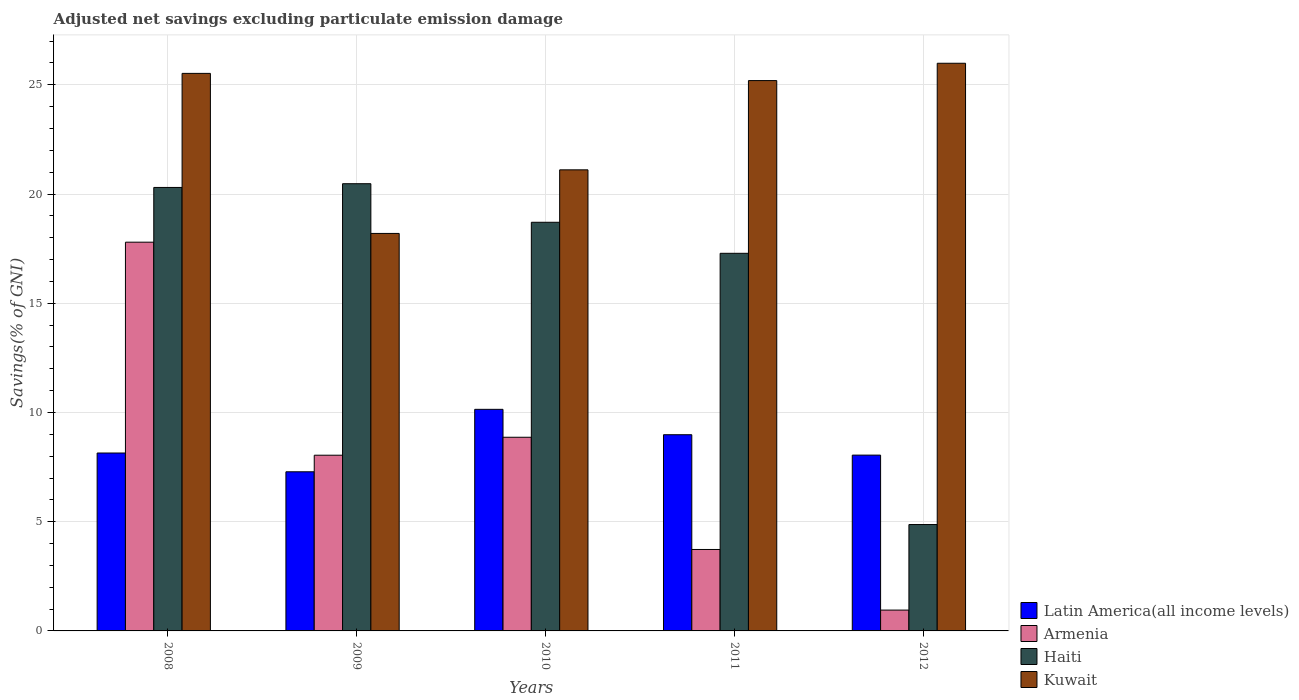How many different coloured bars are there?
Your answer should be compact. 4. Are the number of bars per tick equal to the number of legend labels?
Keep it short and to the point. Yes. Are the number of bars on each tick of the X-axis equal?
Your response must be concise. Yes. How many bars are there on the 3rd tick from the left?
Make the answer very short. 4. How many bars are there on the 2nd tick from the right?
Make the answer very short. 4. In how many cases, is the number of bars for a given year not equal to the number of legend labels?
Your response must be concise. 0. What is the adjusted net savings in Haiti in 2010?
Your answer should be compact. 18.71. Across all years, what is the maximum adjusted net savings in Kuwait?
Make the answer very short. 25.99. Across all years, what is the minimum adjusted net savings in Latin America(all income levels)?
Provide a short and direct response. 7.29. What is the total adjusted net savings in Kuwait in the graph?
Offer a terse response. 116.01. What is the difference between the adjusted net savings in Armenia in 2009 and that in 2011?
Ensure brevity in your answer.  4.32. What is the difference between the adjusted net savings in Armenia in 2008 and the adjusted net savings in Latin America(all income levels) in 2010?
Make the answer very short. 7.65. What is the average adjusted net savings in Haiti per year?
Make the answer very short. 16.33. In the year 2012, what is the difference between the adjusted net savings in Armenia and adjusted net savings in Haiti?
Make the answer very short. -3.92. In how many years, is the adjusted net savings in Latin America(all income levels) greater than 25 %?
Provide a short and direct response. 0. What is the ratio of the adjusted net savings in Latin America(all income levels) in 2008 to that in 2010?
Give a very brief answer. 0.8. What is the difference between the highest and the second highest adjusted net savings in Kuwait?
Your response must be concise. 0.46. What is the difference between the highest and the lowest adjusted net savings in Haiti?
Offer a terse response. 15.6. In how many years, is the adjusted net savings in Haiti greater than the average adjusted net savings in Haiti taken over all years?
Offer a very short reply. 4. What does the 3rd bar from the left in 2010 represents?
Provide a short and direct response. Haiti. What does the 1st bar from the right in 2012 represents?
Give a very brief answer. Kuwait. How many bars are there?
Ensure brevity in your answer.  20. What is the difference between two consecutive major ticks on the Y-axis?
Provide a short and direct response. 5. How many legend labels are there?
Provide a short and direct response. 4. How are the legend labels stacked?
Provide a short and direct response. Vertical. What is the title of the graph?
Offer a terse response. Adjusted net savings excluding particulate emission damage. What is the label or title of the Y-axis?
Offer a terse response. Savings(% of GNI). What is the Savings(% of GNI) of Latin America(all income levels) in 2008?
Your answer should be compact. 8.14. What is the Savings(% of GNI) of Armenia in 2008?
Provide a succinct answer. 17.8. What is the Savings(% of GNI) in Haiti in 2008?
Your answer should be very brief. 20.3. What is the Savings(% of GNI) of Kuwait in 2008?
Provide a short and direct response. 25.52. What is the Savings(% of GNI) of Latin America(all income levels) in 2009?
Keep it short and to the point. 7.29. What is the Savings(% of GNI) in Armenia in 2009?
Make the answer very short. 8.04. What is the Savings(% of GNI) in Haiti in 2009?
Your answer should be very brief. 20.47. What is the Savings(% of GNI) in Kuwait in 2009?
Provide a short and direct response. 18.2. What is the Savings(% of GNI) of Latin America(all income levels) in 2010?
Ensure brevity in your answer.  10.14. What is the Savings(% of GNI) of Armenia in 2010?
Make the answer very short. 8.87. What is the Savings(% of GNI) in Haiti in 2010?
Provide a succinct answer. 18.71. What is the Savings(% of GNI) of Kuwait in 2010?
Give a very brief answer. 21.11. What is the Savings(% of GNI) of Latin America(all income levels) in 2011?
Your response must be concise. 8.98. What is the Savings(% of GNI) in Armenia in 2011?
Your response must be concise. 3.73. What is the Savings(% of GNI) in Haiti in 2011?
Provide a succinct answer. 17.29. What is the Savings(% of GNI) of Kuwait in 2011?
Ensure brevity in your answer.  25.19. What is the Savings(% of GNI) of Latin America(all income levels) in 2012?
Make the answer very short. 8.05. What is the Savings(% of GNI) in Armenia in 2012?
Ensure brevity in your answer.  0.95. What is the Savings(% of GNI) in Haiti in 2012?
Provide a succinct answer. 4.87. What is the Savings(% of GNI) of Kuwait in 2012?
Your response must be concise. 25.99. Across all years, what is the maximum Savings(% of GNI) of Latin America(all income levels)?
Your answer should be compact. 10.14. Across all years, what is the maximum Savings(% of GNI) in Armenia?
Provide a succinct answer. 17.8. Across all years, what is the maximum Savings(% of GNI) of Haiti?
Offer a very short reply. 20.47. Across all years, what is the maximum Savings(% of GNI) in Kuwait?
Offer a very short reply. 25.99. Across all years, what is the minimum Savings(% of GNI) in Latin America(all income levels)?
Give a very brief answer. 7.29. Across all years, what is the minimum Savings(% of GNI) of Armenia?
Ensure brevity in your answer.  0.95. Across all years, what is the minimum Savings(% of GNI) of Haiti?
Your response must be concise. 4.87. Across all years, what is the minimum Savings(% of GNI) of Kuwait?
Provide a succinct answer. 18.2. What is the total Savings(% of GNI) of Latin America(all income levels) in the graph?
Ensure brevity in your answer.  42.6. What is the total Savings(% of GNI) in Armenia in the graph?
Keep it short and to the point. 39.39. What is the total Savings(% of GNI) of Haiti in the graph?
Make the answer very short. 81.64. What is the total Savings(% of GNI) in Kuwait in the graph?
Offer a very short reply. 116.01. What is the difference between the Savings(% of GNI) in Latin America(all income levels) in 2008 and that in 2009?
Provide a succinct answer. 0.86. What is the difference between the Savings(% of GNI) in Armenia in 2008 and that in 2009?
Ensure brevity in your answer.  9.75. What is the difference between the Savings(% of GNI) of Haiti in 2008 and that in 2009?
Offer a terse response. -0.17. What is the difference between the Savings(% of GNI) in Kuwait in 2008 and that in 2009?
Offer a very short reply. 7.33. What is the difference between the Savings(% of GNI) of Latin America(all income levels) in 2008 and that in 2010?
Offer a terse response. -2. What is the difference between the Savings(% of GNI) of Armenia in 2008 and that in 2010?
Provide a short and direct response. 8.93. What is the difference between the Savings(% of GNI) of Haiti in 2008 and that in 2010?
Give a very brief answer. 1.59. What is the difference between the Savings(% of GNI) in Kuwait in 2008 and that in 2010?
Offer a very short reply. 4.42. What is the difference between the Savings(% of GNI) in Latin America(all income levels) in 2008 and that in 2011?
Offer a terse response. -0.84. What is the difference between the Savings(% of GNI) of Armenia in 2008 and that in 2011?
Your response must be concise. 14.07. What is the difference between the Savings(% of GNI) of Haiti in 2008 and that in 2011?
Your response must be concise. 3.02. What is the difference between the Savings(% of GNI) in Kuwait in 2008 and that in 2011?
Provide a short and direct response. 0.33. What is the difference between the Savings(% of GNI) in Latin America(all income levels) in 2008 and that in 2012?
Your answer should be very brief. 0.1. What is the difference between the Savings(% of GNI) in Armenia in 2008 and that in 2012?
Your answer should be compact. 16.84. What is the difference between the Savings(% of GNI) in Haiti in 2008 and that in 2012?
Keep it short and to the point. 15.43. What is the difference between the Savings(% of GNI) in Kuwait in 2008 and that in 2012?
Your response must be concise. -0.46. What is the difference between the Savings(% of GNI) in Latin America(all income levels) in 2009 and that in 2010?
Keep it short and to the point. -2.86. What is the difference between the Savings(% of GNI) of Armenia in 2009 and that in 2010?
Make the answer very short. -0.82. What is the difference between the Savings(% of GNI) of Haiti in 2009 and that in 2010?
Keep it short and to the point. 1.77. What is the difference between the Savings(% of GNI) of Kuwait in 2009 and that in 2010?
Keep it short and to the point. -2.91. What is the difference between the Savings(% of GNI) of Latin America(all income levels) in 2009 and that in 2011?
Offer a very short reply. -1.7. What is the difference between the Savings(% of GNI) in Armenia in 2009 and that in 2011?
Your answer should be compact. 4.32. What is the difference between the Savings(% of GNI) of Haiti in 2009 and that in 2011?
Offer a terse response. 3.19. What is the difference between the Savings(% of GNI) in Kuwait in 2009 and that in 2011?
Your answer should be compact. -7. What is the difference between the Savings(% of GNI) in Latin America(all income levels) in 2009 and that in 2012?
Make the answer very short. -0.76. What is the difference between the Savings(% of GNI) in Armenia in 2009 and that in 2012?
Make the answer very short. 7.09. What is the difference between the Savings(% of GNI) of Haiti in 2009 and that in 2012?
Your answer should be very brief. 15.6. What is the difference between the Savings(% of GNI) in Kuwait in 2009 and that in 2012?
Your answer should be compact. -7.79. What is the difference between the Savings(% of GNI) in Latin America(all income levels) in 2010 and that in 2011?
Keep it short and to the point. 1.16. What is the difference between the Savings(% of GNI) in Armenia in 2010 and that in 2011?
Provide a succinct answer. 5.14. What is the difference between the Savings(% of GNI) of Haiti in 2010 and that in 2011?
Offer a very short reply. 1.42. What is the difference between the Savings(% of GNI) in Kuwait in 2010 and that in 2011?
Provide a short and direct response. -4.09. What is the difference between the Savings(% of GNI) in Latin America(all income levels) in 2010 and that in 2012?
Provide a short and direct response. 2.1. What is the difference between the Savings(% of GNI) in Armenia in 2010 and that in 2012?
Make the answer very short. 7.91. What is the difference between the Savings(% of GNI) of Haiti in 2010 and that in 2012?
Give a very brief answer. 13.84. What is the difference between the Savings(% of GNI) in Kuwait in 2010 and that in 2012?
Ensure brevity in your answer.  -4.88. What is the difference between the Savings(% of GNI) in Latin America(all income levels) in 2011 and that in 2012?
Provide a succinct answer. 0.93. What is the difference between the Savings(% of GNI) of Armenia in 2011 and that in 2012?
Provide a short and direct response. 2.77. What is the difference between the Savings(% of GNI) in Haiti in 2011 and that in 2012?
Your answer should be compact. 12.42. What is the difference between the Savings(% of GNI) in Kuwait in 2011 and that in 2012?
Provide a succinct answer. -0.79. What is the difference between the Savings(% of GNI) of Latin America(all income levels) in 2008 and the Savings(% of GNI) of Armenia in 2009?
Ensure brevity in your answer.  0.1. What is the difference between the Savings(% of GNI) of Latin America(all income levels) in 2008 and the Savings(% of GNI) of Haiti in 2009?
Your answer should be very brief. -12.33. What is the difference between the Savings(% of GNI) in Latin America(all income levels) in 2008 and the Savings(% of GNI) in Kuwait in 2009?
Offer a terse response. -10.05. What is the difference between the Savings(% of GNI) of Armenia in 2008 and the Savings(% of GNI) of Haiti in 2009?
Provide a short and direct response. -2.68. What is the difference between the Savings(% of GNI) of Armenia in 2008 and the Savings(% of GNI) of Kuwait in 2009?
Your answer should be compact. -0.4. What is the difference between the Savings(% of GNI) of Haiti in 2008 and the Savings(% of GNI) of Kuwait in 2009?
Offer a terse response. 2.11. What is the difference between the Savings(% of GNI) of Latin America(all income levels) in 2008 and the Savings(% of GNI) of Armenia in 2010?
Give a very brief answer. -0.72. What is the difference between the Savings(% of GNI) in Latin America(all income levels) in 2008 and the Savings(% of GNI) in Haiti in 2010?
Give a very brief answer. -10.56. What is the difference between the Savings(% of GNI) of Latin America(all income levels) in 2008 and the Savings(% of GNI) of Kuwait in 2010?
Your answer should be very brief. -12.96. What is the difference between the Savings(% of GNI) in Armenia in 2008 and the Savings(% of GNI) in Haiti in 2010?
Provide a short and direct response. -0.91. What is the difference between the Savings(% of GNI) in Armenia in 2008 and the Savings(% of GNI) in Kuwait in 2010?
Make the answer very short. -3.31. What is the difference between the Savings(% of GNI) in Haiti in 2008 and the Savings(% of GNI) in Kuwait in 2010?
Provide a short and direct response. -0.81. What is the difference between the Savings(% of GNI) of Latin America(all income levels) in 2008 and the Savings(% of GNI) of Armenia in 2011?
Offer a terse response. 4.42. What is the difference between the Savings(% of GNI) in Latin America(all income levels) in 2008 and the Savings(% of GNI) in Haiti in 2011?
Provide a succinct answer. -9.14. What is the difference between the Savings(% of GNI) in Latin America(all income levels) in 2008 and the Savings(% of GNI) in Kuwait in 2011?
Keep it short and to the point. -17.05. What is the difference between the Savings(% of GNI) of Armenia in 2008 and the Savings(% of GNI) of Haiti in 2011?
Keep it short and to the point. 0.51. What is the difference between the Savings(% of GNI) of Armenia in 2008 and the Savings(% of GNI) of Kuwait in 2011?
Keep it short and to the point. -7.4. What is the difference between the Savings(% of GNI) in Haiti in 2008 and the Savings(% of GNI) in Kuwait in 2011?
Offer a very short reply. -4.89. What is the difference between the Savings(% of GNI) of Latin America(all income levels) in 2008 and the Savings(% of GNI) of Armenia in 2012?
Offer a very short reply. 7.19. What is the difference between the Savings(% of GNI) of Latin America(all income levels) in 2008 and the Savings(% of GNI) of Haiti in 2012?
Ensure brevity in your answer.  3.27. What is the difference between the Savings(% of GNI) of Latin America(all income levels) in 2008 and the Savings(% of GNI) of Kuwait in 2012?
Make the answer very short. -17.84. What is the difference between the Savings(% of GNI) in Armenia in 2008 and the Savings(% of GNI) in Haiti in 2012?
Provide a succinct answer. 12.93. What is the difference between the Savings(% of GNI) in Armenia in 2008 and the Savings(% of GNI) in Kuwait in 2012?
Keep it short and to the point. -8.19. What is the difference between the Savings(% of GNI) of Haiti in 2008 and the Savings(% of GNI) of Kuwait in 2012?
Make the answer very short. -5.69. What is the difference between the Savings(% of GNI) of Latin America(all income levels) in 2009 and the Savings(% of GNI) of Armenia in 2010?
Provide a short and direct response. -1.58. What is the difference between the Savings(% of GNI) of Latin America(all income levels) in 2009 and the Savings(% of GNI) of Haiti in 2010?
Offer a very short reply. -11.42. What is the difference between the Savings(% of GNI) of Latin America(all income levels) in 2009 and the Savings(% of GNI) of Kuwait in 2010?
Your answer should be compact. -13.82. What is the difference between the Savings(% of GNI) of Armenia in 2009 and the Savings(% of GNI) of Haiti in 2010?
Make the answer very short. -10.66. What is the difference between the Savings(% of GNI) of Armenia in 2009 and the Savings(% of GNI) of Kuwait in 2010?
Your answer should be very brief. -13.06. What is the difference between the Savings(% of GNI) of Haiti in 2009 and the Savings(% of GNI) of Kuwait in 2010?
Your answer should be compact. -0.64. What is the difference between the Savings(% of GNI) in Latin America(all income levels) in 2009 and the Savings(% of GNI) in Armenia in 2011?
Offer a very short reply. 3.56. What is the difference between the Savings(% of GNI) of Latin America(all income levels) in 2009 and the Savings(% of GNI) of Haiti in 2011?
Keep it short and to the point. -10. What is the difference between the Savings(% of GNI) of Latin America(all income levels) in 2009 and the Savings(% of GNI) of Kuwait in 2011?
Your response must be concise. -17.91. What is the difference between the Savings(% of GNI) in Armenia in 2009 and the Savings(% of GNI) in Haiti in 2011?
Provide a succinct answer. -9.24. What is the difference between the Savings(% of GNI) in Armenia in 2009 and the Savings(% of GNI) in Kuwait in 2011?
Your answer should be very brief. -17.15. What is the difference between the Savings(% of GNI) in Haiti in 2009 and the Savings(% of GNI) in Kuwait in 2011?
Provide a succinct answer. -4.72. What is the difference between the Savings(% of GNI) in Latin America(all income levels) in 2009 and the Savings(% of GNI) in Armenia in 2012?
Offer a very short reply. 6.33. What is the difference between the Savings(% of GNI) in Latin America(all income levels) in 2009 and the Savings(% of GNI) in Haiti in 2012?
Provide a short and direct response. 2.42. What is the difference between the Savings(% of GNI) of Latin America(all income levels) in 2009 and the Savings(% of GNI) of Kuwait in 2012?
Your answer should be compact. -18.7. What is the difference between the Savings(% of GNI) in Armenia in 2009 and the Savings(% of GNI) in Haiti in 2012?
Offer a very short reply. 3.17. What is the difference between the Savings(% of GNI) in Armenia in 2009 and the Savings(% of GNI) in Kuwait in 2012?
Your answer should be compact. -17.94. What is the difference between the Savings(% of GNI) of Haiti in 2009 and the Savings(% of GNI) of Kuwait in 2012?
Provide a succinct answer. -5.51. What is the difference between the Savings(% of GNI) of Latin America(all income levels) in 2010 and the Savings(% of GNI) of Armenia in 2011?
Provide a succinct answer. 6.42. What is the difference between the Savings(% of GNI) of Latin America(all income levels) in 2010 and the Savings(% of GNI) of Haiti in 2011?
Offer a very short reply. -7.14. What is the difference between the Savings(% of GNI) of Latin America(all income levels) in 2010 and the Savings(% of GNI) of Kuwait in 2011?
Give a very brief answer. -15.05. What is the difference between the Savings(% of GNI) in Armenia in 2010 and the Savings(% of GNI) in Haiti in 2011?
Ensure brevity in your answer.  -8.42. What is the difference between the Savings(% of GNI) of Armenia in 2010 and the Savings(% of GNI) of Kuwait in 2011?
Offer a terse response. -16.33. What is the difference between the Savings(% of GNI) in Haiti in 2010 and the Savings(% of GNI) in Kuwait in 2011?
Your answer should be compact. -6.49. What is the difference between the Savings(% of GNI) in Latin America(all income levels) in 2010 and the Savings(% of GNI) in Armenia in 2012?
Make the answer very short. 9.19. What is the difference between the Savings(% of GNI) in Latin America(all income levels) in 2010 and the Savings(% of GNI) in Haiti in 2012?
Keep it short and to the point. 5.27. What is the difference between the Savings(% of GNI) in Latin America(all income levels) in 2010 and the Savings(% of GNI) in Kuwait in 2012?
Keep it short and to the point. -15.84. What is the difference between the Savings(% of GNI) of Armenia in 2010 and the Savings(% of GNI) of Haiti in 2012?
Your answer should be compact. 4. What is the difference between the Savings(% of GNI) in Armenia in 2010 and the Savings(% of GNI) in Kuwait in 2012?
Your response must be concise. -17.12. What is the difference between the Savings(% of GNI) in Haiti in 2010 and the Savings(% of GNI) in Kuwait in 2012?
Offer a terse response. -7.28. What is the difference between the Savings(% of GNI) of Latin America(all income levels) in 2011 and the Savings(% of GNI) of Armenia in 2012?
Your answer should be compact. 8.03. What is the difference between the Savings(% of GNI) in Latin America(all income levels) in 2011 and the Savings(% of GNI) in Haiti in 2012?
Provide a succinct answer. 4.11. What is the difference between the Savings(% of GNI) of Latin America(all income levels) in 2011 and the Savings(% of GNI) of Kuwait in 2012?
Ensure brevity in your answer.  -17.01. What is the difference between the Savings(% of GNI) of Armenia in 2011 and the Savings(% of GNI) of Haiti in 2012?
Offer a terse response. -1.14. What is the difference between the Savings(% of GNI) of Armenia in 2011 and the Savings(% of GNI) of Kuwait in 2012?
Provide a succinct answer. -22.26. What is the difference between the Savings(% of GNI) of Haiti in 2011 and the Savings(% of GNI) of Kuwait in 2012?
Ensure brevity in your answer.  -8.7. What is the average Savings(% of GNI) in Latin America(all income levels) per year?
Offer a very short reply. 8.52. What is the average Savings(% of GNI) in Armenia per year?
Your answer should be compact. 7.88. What is the average Savings(% of GNI) in Haiti per year?
Provide a succinct answer. 16.33. What is the average Savings(% of GNI) of Kuwait per year?
Ensure brevity in your answer.  23.2. In the year 2008, what is the difference between the Savings(% of GNI) of Latin America(all income levels) and Savings(% of GNI) of Armenia?
Offer a very short reply. -9.65. In the year 2008, what is the difference between the Savings(% of GNI) in Latin America(all income levels) and Savings(% of GNI) in Haiti?
Your response must be concise. -12.16. In the year 2008, what is the difference between the Savings(% of GNI) of Latin America(all income levels) and Savings(% of GNI) of Kuwait?
Your answer should be very brief. -17.38. In the year 2008, what is the difference between the Savings(% of GNI) in Armenia and Savings(% of GNI) in Haiti?
Your response must be concise. -2.51. In the year 2008, what is the difference between the Savings(% of GNI) of Armenia and Savings(% of GNI) of Kuwait?
Make the answer very short. -7.73. In the year 2008, what is the difference between the Savings(% of GNI) in Haiti and Savings(% of GNI) in Kuwait?
Offer a very short reply. -5.22. In the year 2009, what is the difference between the Savings(% of GNI) in Latin America(all income levels) and Savings(% of GNI) in Armenia?
Make the answer very short. -0.76. In the year 2009, what is the difference between the Savings(% of GNI) in Latin America(all income levels) and Savings(% of GNI) in Haiti?
Offer a terse response. -13.19. In the year 2009, what is the difference between the Savings(% of GNI) of Latin America(all income levels) and Savings(% of GNI) of Kuwait?
Your answer should be very brief. -10.91. In the year 2009, what is the difference between the Savings(% of GNI) of Armenia and Savings(% of GNI) of Haiti?
Keep it short and to the point. -12.43. In the year 2009, what is the difference between the Savings(% of GNI) in Armenia and Savings(% of GNI) in Kuwait?
Your answer should be very brief. -10.15. In the year 2009, what is the difference between the Savings(% of GNI) of Haiti and Savings(% of GNI) of Kuwait?
Keep it short and to the point. 2.28. In the year 2010, what is the difference between the Savings(% of GNI) of Latin America(all income levels) and Savings(% of GNI) of Armenia?
Ensure brevity in your answer.  1.28. In the year 2010, what is the difference between the Savings(% of GNI) in Latin America(all income levels) and Savings(% of GNI) in Haiti?
Ensure brevity in your answer.  -8.56. In the year 2010, what is the difference between the Savings(% of GNI) in Latin America(all income levels) and Savings(% of GNI) in Kuwait?
Provide a short and direct response. -10.96. In the year 2010, what is the difference between the Savings(% of GNI) in Armenia and Savings(% of GNI) in Haiti?
Your response must be concise. -9.84. In the year 2010, what is the difference between the Savings(% of GNI) in Armenia and Savings(% of GNI) in Kuwait?
Your answer should be compact. -12.24. In the year 2010, what is the difference between the Savings(% of GNI) in Haiti and Savings(% of GNI) in Kuwait?
Make the answer very short. -2.4. In the year 2011, what is the difference between the Savings(% of GNI) in Latin America(all income levels) and Savings(% of GNI) in Armenia?
Keep it short and to the point. 5.25. In the year 2011, what is the difference between the Savings(% of GNI) of Latin America(all income levels) and Savings(% of GNI) of Haiti?
Keep it short and to the point. -8.31. In the year 2011, what is the difference between the Savings(% of GNI) of Latin America(all income levels) and Savings(% of GNI) of Kuwait?
Offer a very short reply. -16.21. In the year 2011, what is the difference between the Savings(% of GNI) in Armenia and Savings(% of GNI) in Haiti?
Your answer should be compact. -13.56. In the year 2011, what is the difference between the Savings(% of GNI) in Armenia and Savings(% of GNI) in Kuwait?
Offer a very short reply. -21.47. In the year 2011, what is the difference between the Savings(% of GNI) in Haiti and Savings(% of GNI) in Kuwait?
Make the answer very short. -7.91. In the year 2012, what is the difference between the Savings(% of GNI) in Latin America(all income levels) and Savings(% of GNI) in Armenia?
Make the answer very short. 7.09. In the year 2012, what is the difference between the Savings(% of GNI) of Latin America(all income levels) and Savings(% of GNI) of Haiti?
Provide a succinct answer. 3.18. In the year 2012, what is the difference between the Savings(% of GNI) of Latin America(all income levels) and Savings(% of GNI) of Kuwait?
Keep it short and to the point. -17.94. In the year 2012, what is the difference between the Savings(% of GNI) in Armenia and Savings(% of GNI) in Haiti?
Your answer should be very brief. -3.92. In the year 2012, what is the difference between the Savings(% of GNI) in Armenia and Savings(% of GNI) in Kuwait?
Offer a very short reply. -25.03. In the year 2012, what is the difference between the Savings(% of GNI) in Haiti and Savings(% of GNI) in Kuwait?
Your answer should be very brief. -21.12. What is the ratio of the Savings(% of GNI) in Latin America(all income levels) in 2008 to that in 2009?
Ensure brevity in your answer.  1.12. What is the ratio of the Savings(% of GNI) in Armenia in 2008 to that in 2009?
Provide a short and direct response. 2.21. What is the ratio of the Savings(% of GNI) of Haiti in 2008 to that in 2009?
Give a very brief answer. 0.99. What is the ratio of the Savings(% of GNI) of Kuwait in 2008 to that in 2009?
Make the answer very short. 1.4. What is the ratio of the Savings(% of GNI) in Latin America(all income levels) in 2008 to that in 2010?
Your answer should be compact. 0.8. What is the ratio of the Savings(% of GNI) in Armenia in 2008 to that in 2010?
Offer a terse response. 2.01. What is the ratio of the Savings(% of GNI) in Haiti in 2008 to that in 2010?
Provide a short and direct response. 1.09. What is the ratio of the Savings(% of GNI) in Kuwait in 2008 to that in 2010?
Your answer should be very brief. 1.21. What is the ratio of the Savings(% of GNI) of Latin America(all income levels) in 2008 to that in 2011?
Offer a terse response. 0.91. What is the ratio of the Savings(% of GNI) of Armenia in 2008 to that in 2011?
Ensure brevity in your answer.  4.77. What is the ratio of the Savings(% of GNI) in Haiti in 2008 to that in 2011?
Provide a succinct answer. 1.17. What is the ratio of the Savings(% of GNI) in Kuwait in 2008 to that in 2011?
Give a very brief answer. 1.01. What is the ratio of the Savings(% of GNI) in Armenia in 2008 to that in 2012?
Provide a short and direct response. 18.65. What is the ratio of the Savings(% of GNI) of Haiti in 2008 to that in 2012?
Give a very brief answer. 4.17. What is the ratio of the Savings(% of GNI) in Kuwait in 2008 to that in 2012?
Provide a succinct answer. 0.98. What is the ratio of the Savings(% of GNI) of Latin America(all income levels) in 2009 to that in 2010?
Make the answer very short. 0.72. What is the ratio of the Savings(% of GNI) of Armenia in 2009 to that in 2010?
Keep it short and to the point. 0.91. What is the ratio of the Savings(% of GNI) in Haiti in 2009 to that in 2010?
Your answer should be compact. 1.09. What is the ratio of the Savings(% of GNI) in Kuwait in 2009 to that in 2010?
Provide a short and direct response. 0.86. What is the ratio of the Savings(% of GNI) in Latin America(all income levels) in 2009 to that in 2011?
Your answer should be very brief. 0.81. What is the ratio of the Savings(% of GNI) of Armenia in 2009 to that in 2011?
Give a very brief answer. 2.16. What is the ratio of the Savings(% of GNI) of Haiti in 2009 to that in 2011?
Your answer should be compact. 1.18. What is the ratio of the Savings(% of GNI) in Kuwait in 2009 to that in 2011?
Offer a terse response. 0.72. What is the ratio of the Savings(% of GNI) of Latin America(all income levels) in 2009 to that in 2012?
Make the answer very short. 0.91. What is the ratio of the Savings(% of GNI) in Armenia in 2009 to that in 2012?
Your answer should be compact. 8.43. What is the ratio of the Savings(% of GNI) of Haiti in 2009 to that in 2012?
Provide a succinct answer. 4.2. What is the ratio of the Savings(% of GNI) of Kuwait in 2009 to that in 2012?
Offer a very short reply. 0.7. What is the ratio of the Savings(% of GNI) of Latin America(all income levels) in 2010 to that in 2011?
Your answer should be very brief. 1.13. What is the ratio of the Savings(% of GNI) in Armenia in 2010 to that in 2011?
Provide a short and direct response. 2.38. What is the ratio of the Savings(% of GNI) in Haiti in 2010 to that in 2011?
Your response must be concise. 1.08. What is the ratio of the Savings(% of GNI) in Kuwait in 2010 to that in 2011?
Your response must be concise. 0.84. What is the ratio of the Savings(% of GNI) in Latin America(all income levels) in 2010 to that in 2012?
Give a very brief answer. 1.26. What is the ratio of the Savings(% of GNI) in Armenia in 2010 to that in 2012?
Offer a very short reply. 9.29. What is the ratio of the Savings(% of GNI) in Haiti in 2010 to that in 2012?
Keep it short and to the point. 3.84. What is the ratio of the Savings(% of GNI) in Kuwait in 2010 to that in 2012?
Provide a short and direct response. 0.81. What is the ratio of the Savings(% of GNI) in Latin America(all income levels) in 2011 to that in 2012?
Ensure brevity in your answer.  1.12. What is the ratio of the Savings(% of GNI) of Armenia in 2011 to that in 2012?
Offer a terse response. 3.91. What is the ratio of the Savings(% of GNI) in Haiti in 2011 to that in 2012?
Keep it short and to the point. 3.55. What is the ratio of the Savings(% of GNI) of Kuwait in 2011 to that in 2012?
Provide a succinct answer. 0.97. What is the difference between the highest and the second highest Savings(% of GNI) of Latin America(all income levels)?
Provide a succinct answer. 1.16. What is the difference between the highest and the second highest Savings(% of GNI) in Armenia?
Your response must be concise. 8.93. What is the difference between the highest and the second highest Savings(% of GNI) of Haiti?
Provide a short and direct response. 0.17. What is the difference between the highest and the second highest Savings(% of GNI) of Kuwait?
Offer a very short reply. 0.46. What is the difference between the highest and the lowest Savings(% of GNI) of Latin America(all income levels)?
Offer a terse response. 2.86. What is the difference between the highest and the lowest Savings(% of GNI) in Armenia?
Provide a succinct answer. 16.84. What is the difference between the highest and the lowest Savings(% of GNI) of Haiti?
Provide a succinct answer. 15.6. What is the difference between the highest and the lowest Savings(% of GNI) of Kuwait?
Keep it short and to the point. 7.79. 